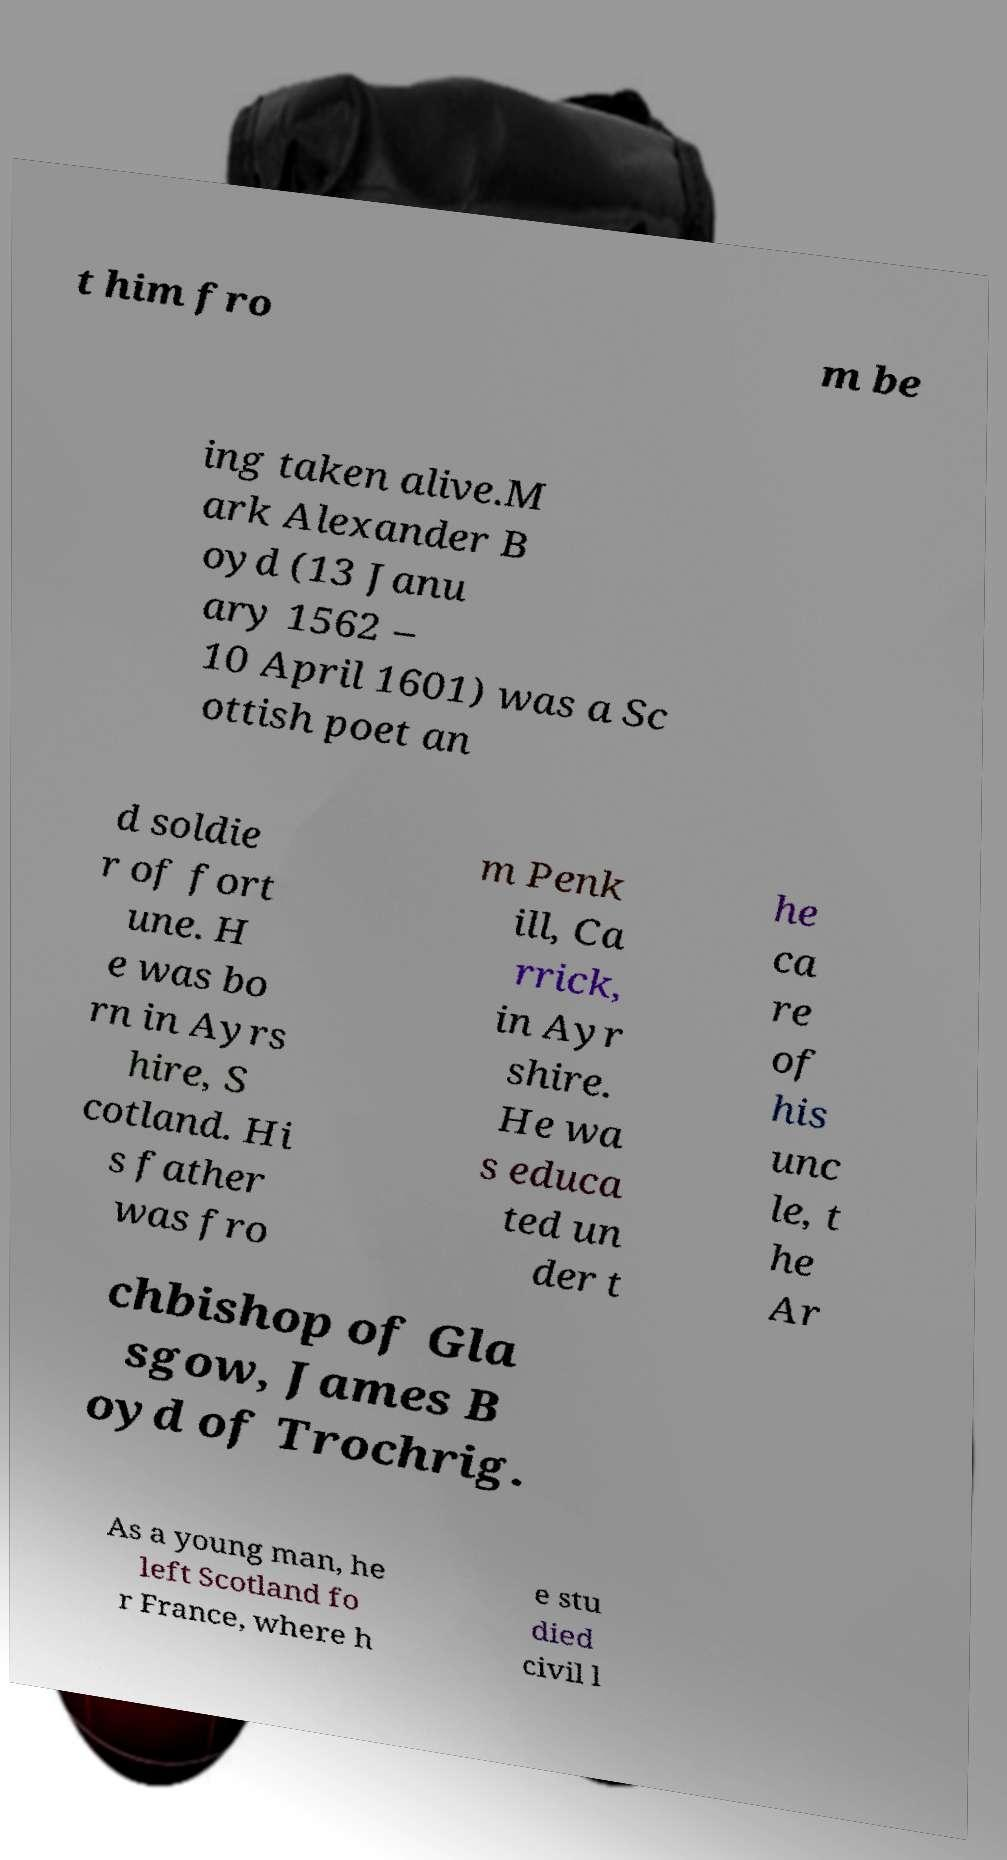Can you accurately transcribe the text from the provided image for me? t him fro m be ing taken alive.M ark Alexander B oyd (13 Janu ary 1562 – 10 April 1601) was a Sc ottish poet an d soldie r of fort une. H e was bo rn in Ayrs hire, S cotland. Hi s father was fro m Penk ill, Ca rrick, in Ayr shire. He wa s educa ted un der t he ca re of his unc le, t he Ar chbishop of Gla sgow, James B oyd of Trochrig. As a young man, he left Scotland fo r France, where h e stu died civil l 